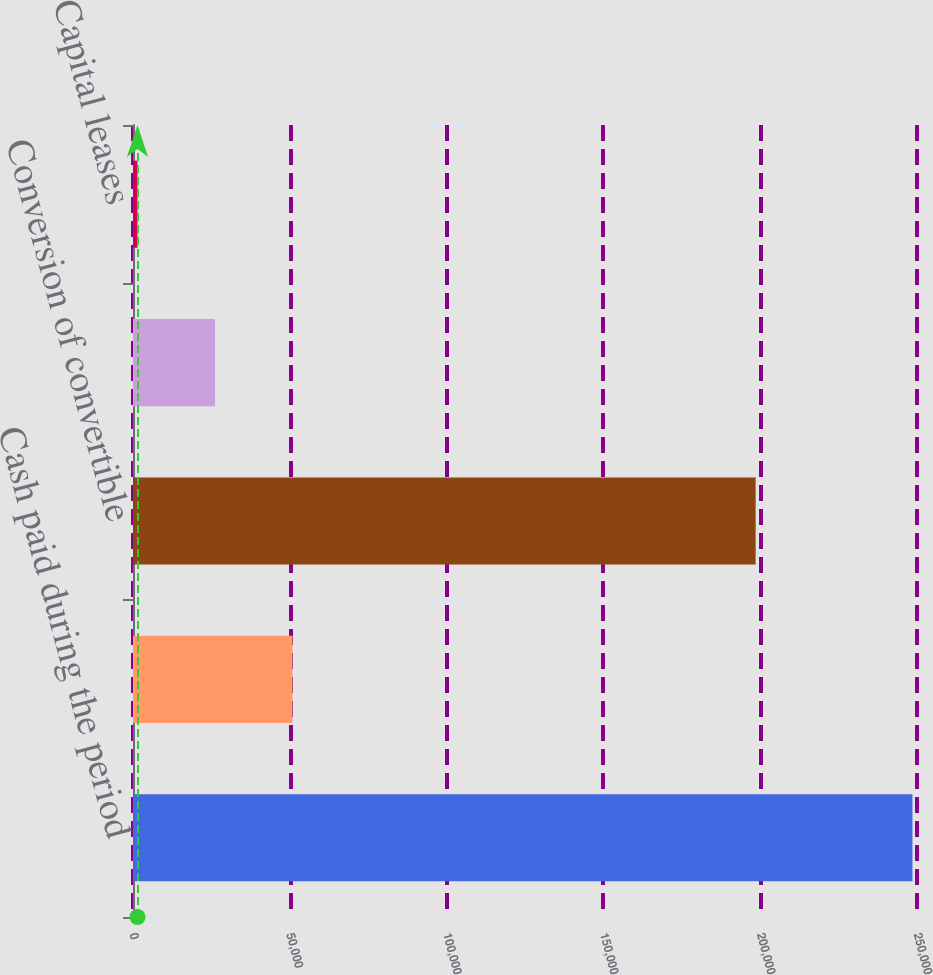<chart> <loc_0><loc_0><loc_500><loc_500><bar_chart><fcel>Cash paid during the period<fcel>Cash paid (received) during<fcel>Conversion of convertible<fcel>Decrease in accounts payable<fcel>Capital leases<nl><fcel>248551<fcel>50861.4<fcel>198545<fcel>26150.2<fcel>1439<nl></chart> 